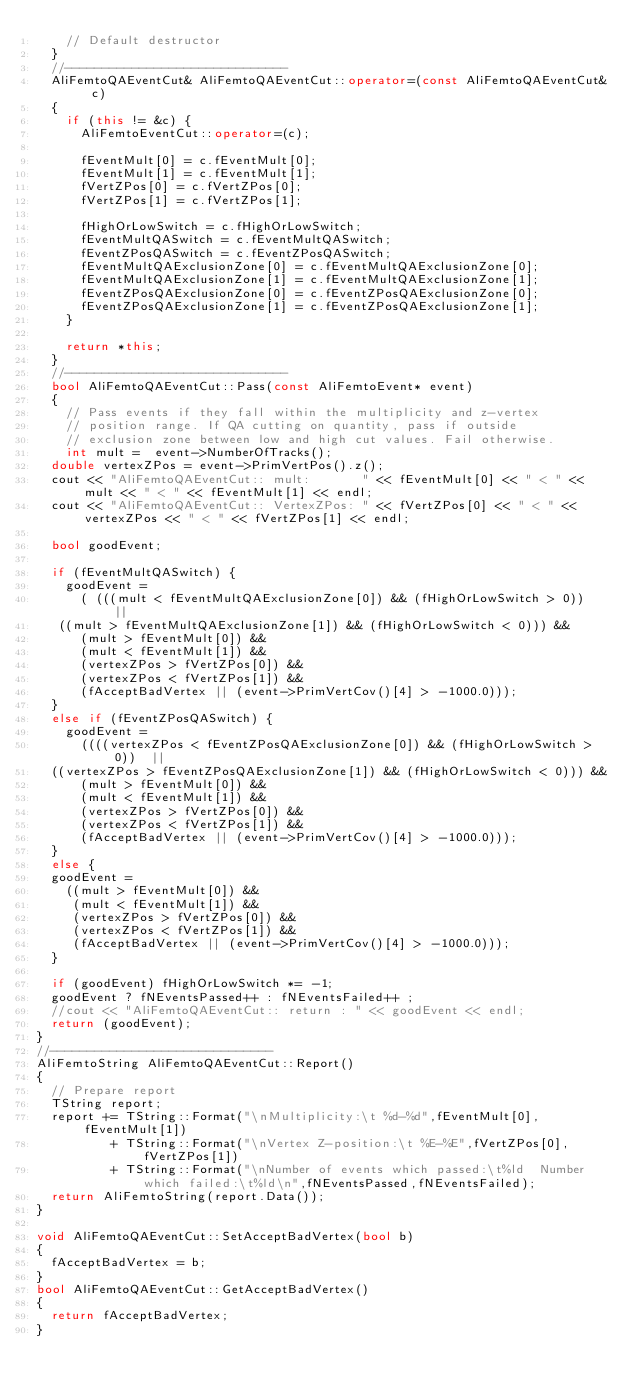<code> <loc_0><loc_0><loc_500><loc_500><_C++_>    // Default destructor
  }
  //------------------------------
  AliFemtoQAEventCut& AliFemtoQAEventCut::operator=(const AliFemtoQAEventCut& c)
  {
    if (this != &c) {
      AliFemtoEventCut::operator=(c);

      fEventMult[0] = c.fEventMult[0];
      fEventMult[1] = c.fEventMult[1];
      fVertZPos[0] = c.fVertZPos[0];
      fVertZPos[1] = c.fVertZPos[1];

      fHighOrLowSwitch = c.fHighOrLowSwitch;
      fEventMultQASwitch = c.fEventMultQASwitch;
      fEventZPosQASwitch = c.fEventZPosQASwitch;
      fEventMultQAExclusionZone[0] = c.fEventMultQAExclusionZone[0];
      fEventMultQAExclusionZone[1] = c.fEventMultQAExclusionZone[1];
      fEventZPosQAExclusionZone[0] = c.fEventZPosQAExclusionZone[0];
      fEventZPosQAExclusionZone[1] = c.fEventZPosQAExclusionZone[1];
    }

    return *this;
  }
  //------------------------------
  bool AliFemtoQAEventCut::Pass(const AliFemtoEvent* event)
  {
    // Pass events if they fall within the multiplicity and z-vertex
    // position range. If QA cutting on quantity, pass if outside
    // exclusion zone between low and high cut values. Fail otherwise.
    int mult =  event->NumberOfTracks();
  double vertexZPos = event->PrimVertPos().z();
  cout << "AliFemtoQAEventCut:: mult:       " << fEventMult[0] << " < " << mult << " < " << fEventMult[1] << endl;
  cout << "AliFemtoQAEventCut:: VertexZPos: " << fVertZPos[0] << " < " << vertexZPos << " < " << fVertZPos[1] << endl;

  bool goodEvent;

  if (fEventMultQASwitch) {
    goodEvent =
      ( (((mult < fEventMultQAExclusionZone[0]) && (fHighOrLowSwitch > 0))  ||
	 ((mult > fEventMultQAExclusionZone[1]) && (fHighOrLowSwitch < 0))) &&
      (mult > fEventMult[0]) &&
      (mult < fEventMult[1]) &&
      (vertexZPos > fVertZPos[0]) &&
      (vertexZPos < fVertZPos[1]) &&
      (fAcceptBadVertex || (event->PrimVertCov()[4] > -1000.0)));
  }
  else if (fEventZPosQASwitch) {
    goodEvent =
      ((((vertexZPos < fEventZPosQAExclusionZone[0]) && (fHighOrLowSwitch > 0))  ||
	((vertexZPos > fEventZPosQAExclusionZone[1]) && (fHighOrLowSwitch < 0))) &&
      (mult > fEventMult[0]) &&
      (mult < fEventMult[1]) &&
      (vertexZPos > fVertZPos[0]) &&
      (vertexZPos < fVertZPos[1]) &&
      (fAcceptBadVertex || (event->PrimVertCov()[4] > -1000.0)));
  }
  else {
  goodEvent =
    ((mult > fEventMult[0]) &&
     (mult < fEventMult[1]) &&
     (vertexZPos > fVertZPos[0]) &&
     (vertexZPos < fVertZPos[1]) &&
     (fAcceptBadVertex || (event->PrimVertCov()[4] > -1000.0)));
  }

  if (goodEvent) fHighOrLowSwitch *= -1;
  goodEvent ? fNEventsPassed++ : fNEventsFailed++ ;
  //cout << "AliFemtoQAEventCut:: return : " << goodEvent << endl;
  return (goodEvent);
}
//------------------------------
AliFemtoString AliFemtoQAEventCut::Report()
{
  // Prepare report
  TString report;
  report += TString::Format("\nMultiplicity:\t %d-%d",fEventMult[0],fEventMult[1])
          + TString::Format("\nVertex Z-position:\t %E-%E",fVertZPos[0],fVertZPos[1])
          + TString::Format("\nNumber of events which passed:\t%ld  Number which failed:\t%ld\n",fNEventsPassed,fNEventsFailed);
  return AliFemtoString(report.Data());
}

void AliFemtoQAEventCut::SetAcceptBadVertex(bool b)
{
  fAcceptBadVertex = b;
}
bool AliFemtoQAEventCut::GetAcceptBadVertex()
{
  return fAcceptBadVertex;
}
</code> 